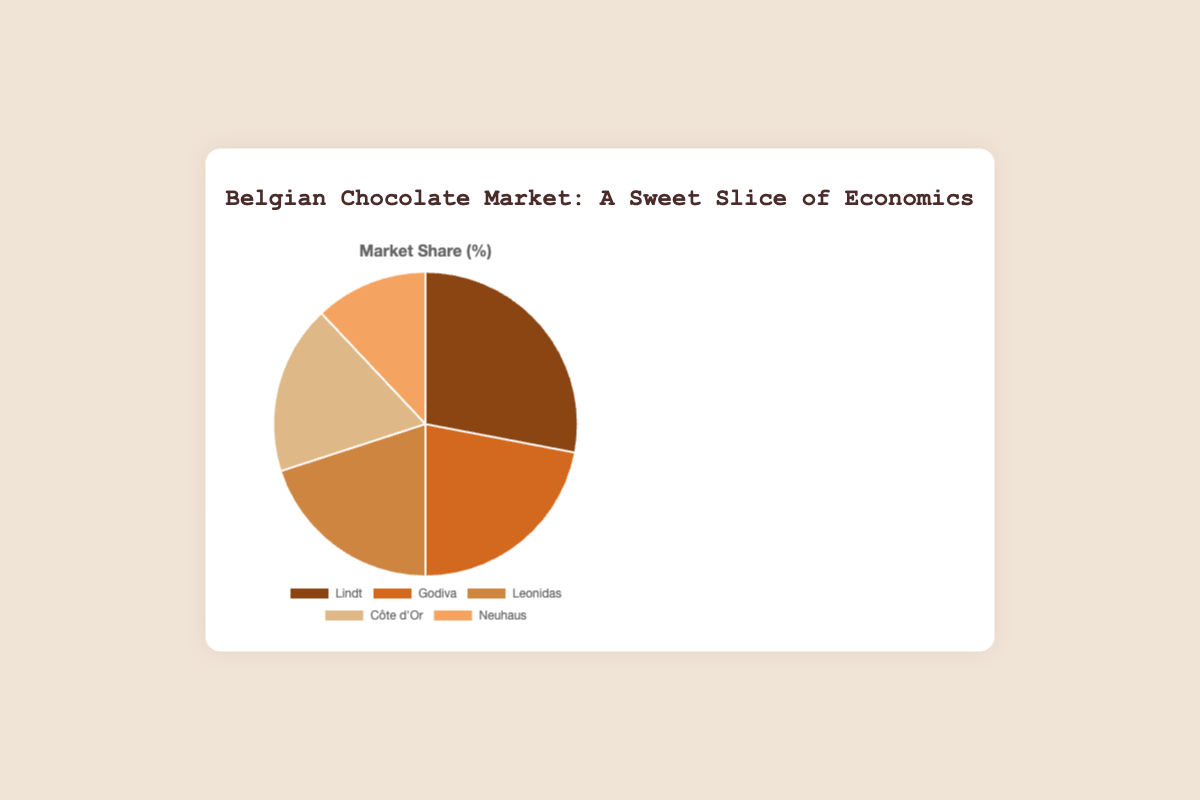What is the market share of Godiva? Look at the pie slice labeled "Godiva" and note the percentage next to it.
Answer: 22% Which manufacturer has the smallest market share? Identify the pie slice with the smallest area or check the labels and percentages to find the lowest one.
Answer: Neuhaus What is the combined market share of Lindt and Leonidas? Identify the market shares of Lindt and Leonidas (28% and 20%, respectively) and sum them up: 28% + 20% = 48%
Answer: 48% Which manufacturer has a market share greater than 20% but less than 30%? Identify the pie slices with labels and percentages. Look for a percentage between 20% and 30%. Godiva has 22% and Lindt has 28%. The one that fits this range is Godiva.
Answer: Godiva How much larger is Lindt's market share compared to Neuhaus's? Find the percentages for Lindt and Neuhaus, then subtract Neuhaus's percentage from Lindt's. 28% - 12% = 16%
Answer: 16% What is the total market share of manufacturers other than Côte d'Or? Identify the market share of Côte d'Or (18%) and subtract it from 100% to get the combined market share of the rest: 100% - 18% = 82%
Answer: 82% If Leonidas increases its market share by 5%, what would their new market share be? Add 5% to Leonidas's current market share (20%): 20% + 5% = 25%
Answer: 25% Which two manufacturers have the closest market shares, and what is the difference? Compare each pair of neighboring manufacturers' market shares and find the smallest difference. Godiva (22%) and Leonidas (20%) have the closest market shares. The difference is 22% - 20% = 2%
Answer: Godiva and Leonidas; 2% What color represents the manufacturer with 12% market share? Look at the color of the pie slice corresponding to Neuhaus, which has 12% of the market share. The color is light tan.
Answer: Light tan (F4A460) What is the average market share of all five manufacturers? Sum the market shares of all manufacturers and divide by the number of manufacturers: (28% + 22% + 20% + 18% + 12%) / 5 = 100% / 5 = 20%
Answer: 20% 